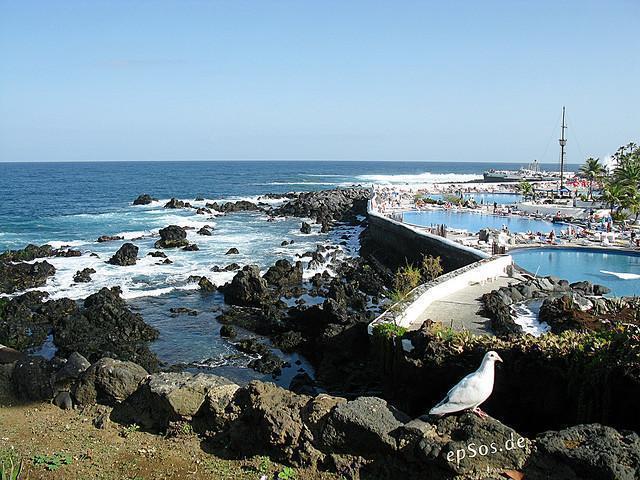What venue is shown on the right?
Choose the correct response, then elucidate: 'Answer: answer
Rationale: rationale.'
Options: Resort area, water park, beach, reservoir. Answer: resort area.
Rationale: There are several pools and decks with a lot of chairs 